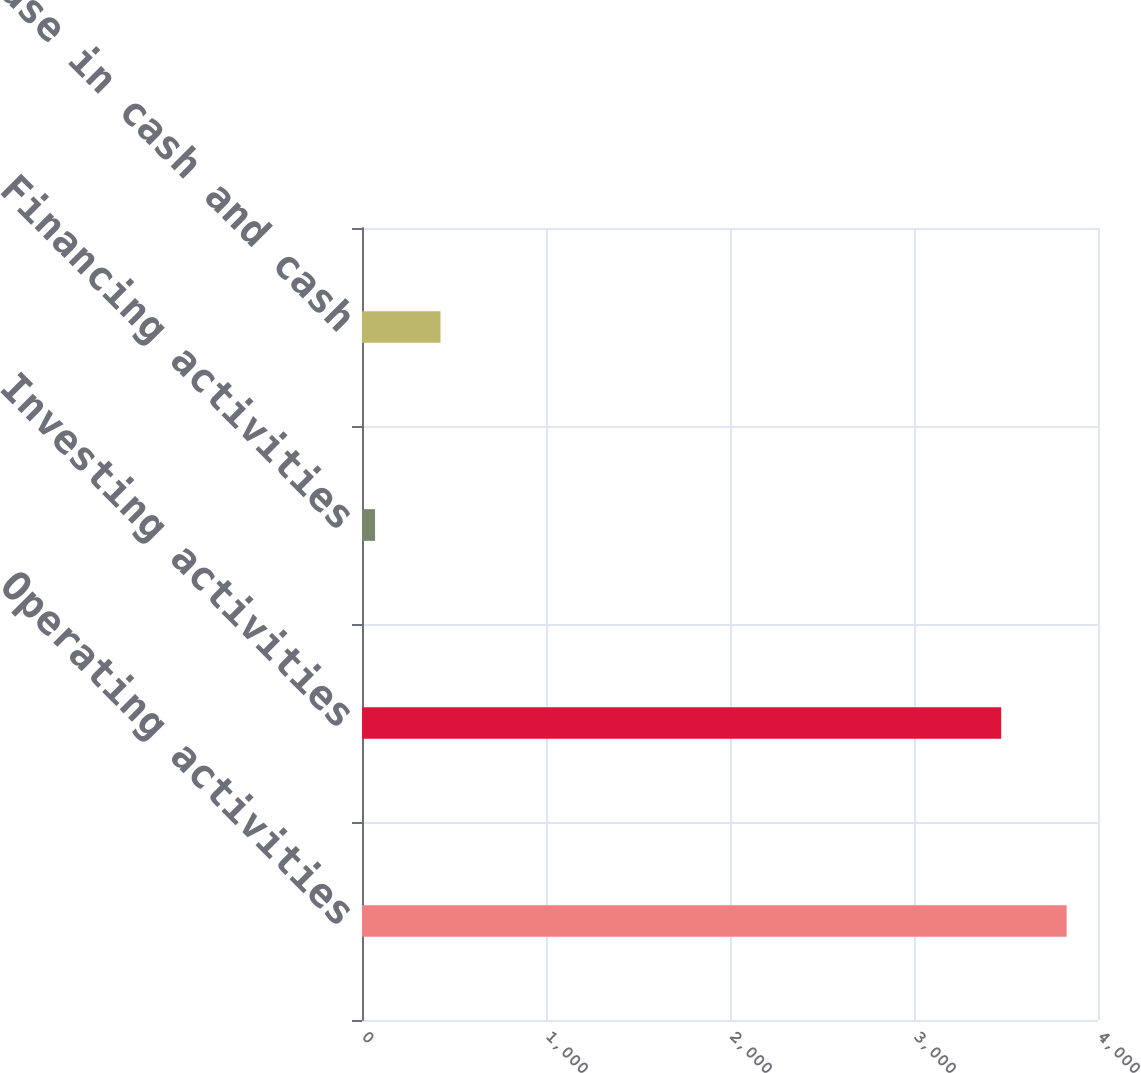Convert chart. <chart><loc_0><loc_0><loc_500><loc_500><bar_chart><fcel>Operating activities<fcel>Investing activities<fcel>Financing activities<fcel>Net increase in cash and cash<nl><fcel>3829.6<fcel>3474<fcel>71<fcel>426.6<nl></chart> 